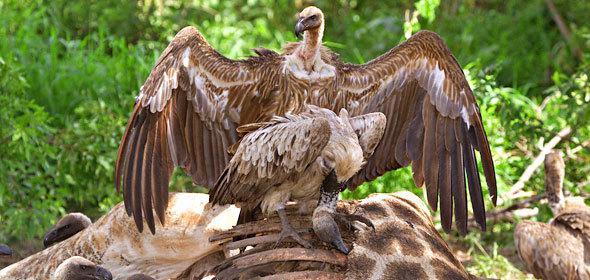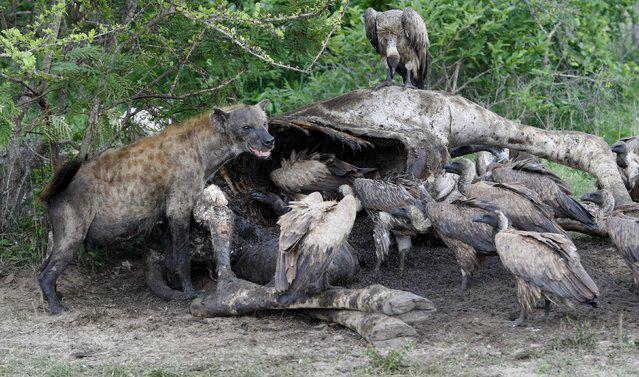The first image is the image on the left, the second image is the image on the right. For the images displayed, is the sentence "In at least one image there is a total of five vultures." factually correct? Answer yes or no. No. The first image is the image on the left, the second image is the image on the right. Given the left and right images, does the statement "An image shows two vultures in the foreground, at least one with its wings outspread." hold true? Answer yes or no. Yes. 